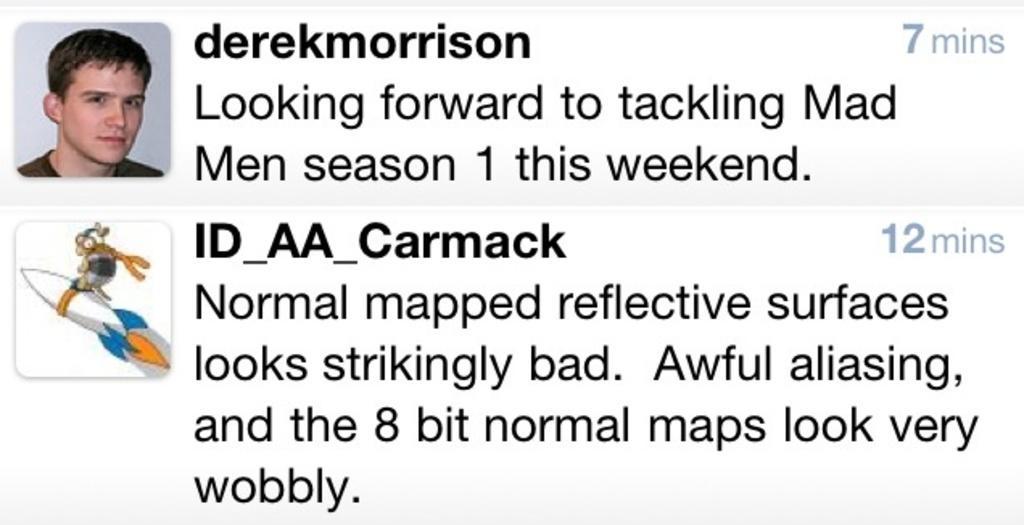Please provide a concise description of this image. In this picture, we can see a screenshot of a web page, and we can see some images and text on it. 